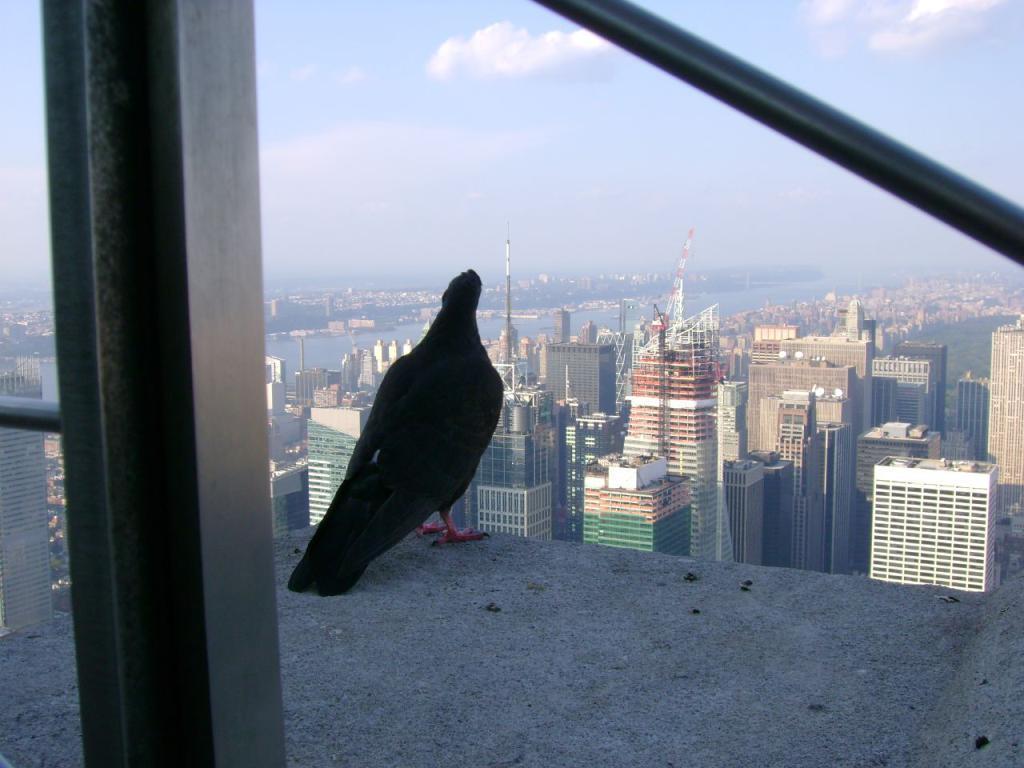Please provide a concise description of this image. On the left side, there is a glass window. Beside this glass window, there is a bird standing on a wall. In the background, there are trees, water and buildings on the ground and there are clouds in the blue sky. 